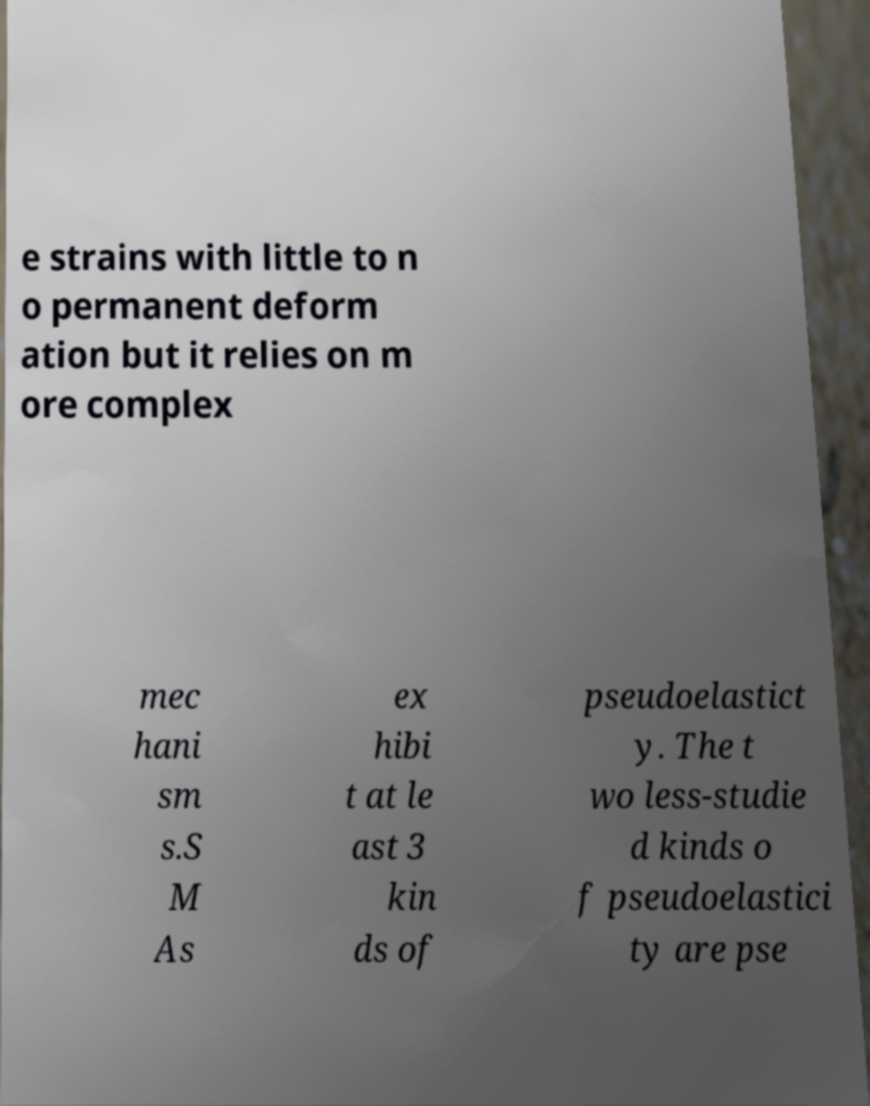What messages or text are displayed in this image? I need them in a readable, typed format. e strains with little to n o permanent deform ation but it relies on m ore complex mec hani sm s.S M As ex hibi t at le ast 3 kin ds of pseudoelastict y. The t wo less-studie d kinds o f pseudoelastici ty are pse 